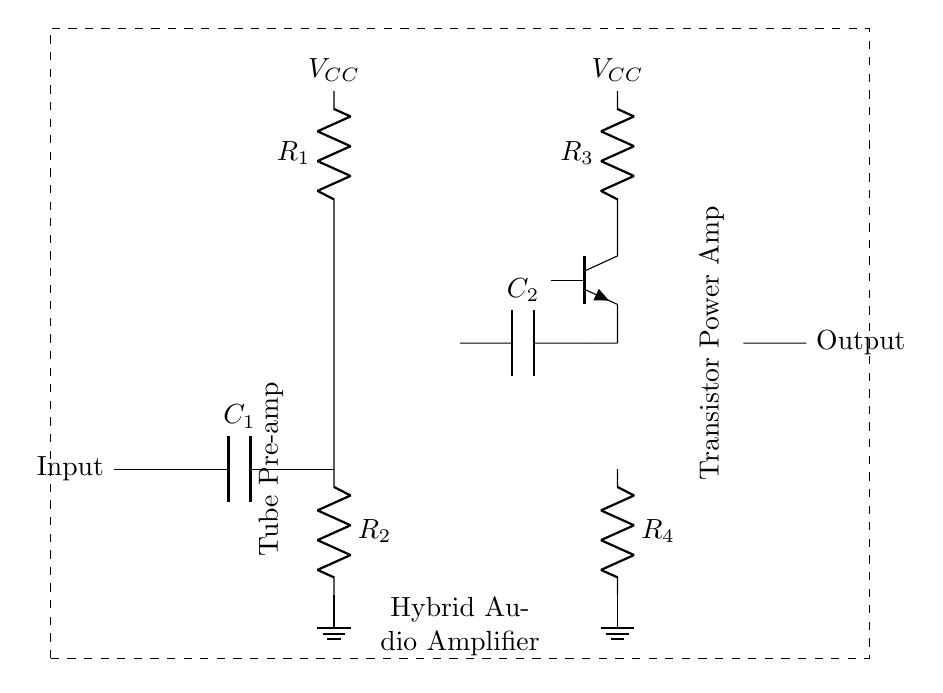What type of amplifier is this circuit? This circuit is a hybrid audio amplifier, combining vacuum tube and solid-state technologies for improved sound quality. The presence of a triode indicates the tube stage, while the transistor signifies the solid-state section.
Answer: hybrid audio amplifier What is the function of capacitor C1? Capacitor C1 acts as a coupling capacitor that blocks DC while allowing AC signals to pass from the input to the tube stage. This ensures that only the audio signal reaches the triode amplifier without any DC component that could affect the performance.
Answer: coupling capacitor What is the configuration of the second amplification stage? The second amplification stage is a transistor, specifically a Tnpn (NPN transistor), which amplifies the signal received from the tube stage. Its configuration is common-emitter, known for providing considerable gain and being the predominant form of transistor amplifier circuits.
Answer: common-emitter What are the voltage levels labeled in the circuit? The voltage levels in the circuit are identified as Vcc, which indicates the common supply voltage for both the tube and the solid-state components, typically a high voltage for the tube and a lower voltage for the transistor section.
Answer: Vcc Why use a triode in this circuit? The triode is used in the circuit for its ability to provide warm sound characteristics, which are often sought after in high-fidelity audio systems to enhance the musicality and depth of the audio output. The unique nonlinear response of the triode complements the solid-state stage's efficiency.
Answer: warm sound What is the purpose of the resistors R1 and R2? Resistor R1 is used for plate load in the triode stage to set the gain and linearity of the amplifier, while R2 acts as a cathode resistor, providing biasing and stability for the tube operation. Both are crucial for ensuring optimal performance of the tube amplifier stage.
Answer: gain and biasing Which component primarily affects the output quality of this hybrid amplifier? The output quality is primarily affected by the tube stage, as it contributes the warmth and coloration of the sound, while the solid-state stage provides efficiency and power required to drive speakers effectively, thus making the tube stage critical for character.
Answer: tube stage 